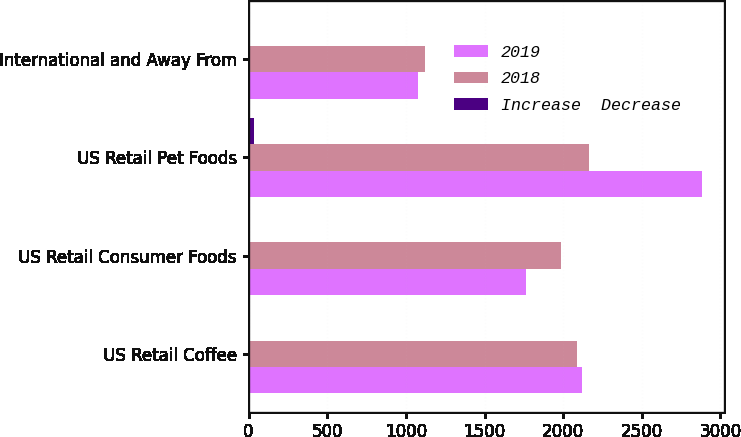Convert chart. <chart><loc_0><loc_0><loc_500><loc_500><stacked_bar_chart><ecel><fcel>US Retail Coffee<fcel>US Retail Consumer Foods<fcel>US Retail Pet Foods<fcel>International and Away From<nl><fcel>2019<fcel>2122.3<fcel>1761.5<fcel>2879.5<fcel>1074.7<nl><fcel>2018<fcel>2086.8<fcel>1985.6<fcel>2165.3<fcel>1119.4<nl><fcel>Increase  Decrease<fcel>2<fcel>11<fcel>33<fcel>4<nl></chart> 